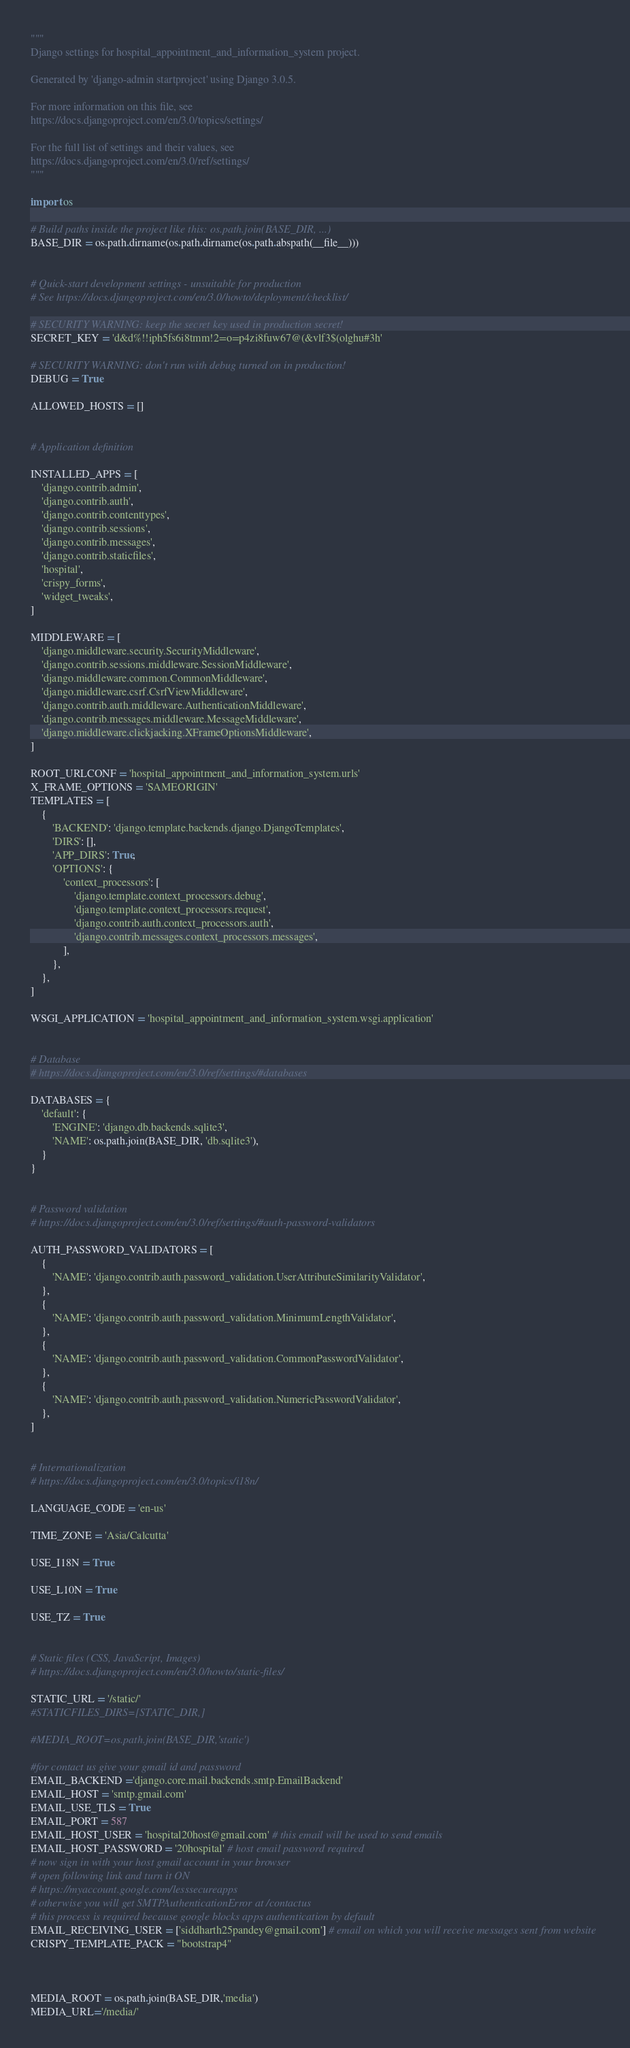<code> <loc_0><loc_0><loc_500><loc_500><_Python_>"""
Django settings for hospital_appointment_and_information_system project.

Generated by 'django-admin startproject' using Django 3.0.5.

For more information on this file, see
https://docs.djangoproject.com/en/3.0/topics/settings/

For the full list of settings and their values, see
https://docs.djangoproject.com/en/3.0/ref/settings/
"""

import os

# Build paths inside the project like this: os.path.join(BASE_DIR, ...)
BASE_DIR = os.path.dirname(os.path.dirname(os.path.abspath(__file__)))


# Quick-start development settings - unsuitable for production
# See https://docs.djangoproject.com/en/3.0/howto/deployment/checklist/

# SECURITY WARNING: keep the secret key used in production secret!
SECRET_KEY = 'd&d%!!iph5fs6i8tmm!2=o=p4zi8fuw67@(&vlf3$(olghu#3h'

# SECURITY WARNING: don't run with debug turned on in production!
DEBUG = True

ALLOWED_HOSTS = []


# Application definition

INSTALLED_APPS = [
    'django.contrib.admin',
    'django.contrib.auth',
    'django.contrib.contenttypes',
    'django.contrib.sessions',
    'django.contrib.messages',
    'django.contrib.staticfiles',
    'hospital',
    'crispy_forms',
    'widget_tweaks',
]

MIDDLEWARE = [
    'django.middleware.security.SecurityMiddleware',
    'django.contrib.sessions.middleware.SessionMiddleware',
    'django.middleware.common.CommonMiddleware',
    'django.middleware.csrf.CsrfViewMiddleware',
    'django.contrib.auth.middleware.AuthenticationMiddleware',
    'django.contrib.messages.middleware.MessageMiddleware',
    'django.middleware.clickjacking.XFrameOptionsMiddleware',
]

ROOT_URLCONF = 'hospital_appointment_and_information_system.urls'
X_FRAME_OPTIONS = 'SAMEORIGIN'
TEMPLATES = [
    {
        'BACKEND': 'django.template.backends.django.DjangoTemplates',
        'DIRS': [],
        'APP_DIRS': True,
        'OPTIONS': {
            'context_processors': [
                'django.template.context_processors.debug',
                'django.template.context_processors.request',
                'django.contrib.auth.context_processors.auth',
                'django.contrib.messages.context_processors.messages',
            ],
        },
    },
]

WSGI_APPLICATION = 'hospital_appointment_and_information_system.wsgi.application'


# Database
# https://docs.djangoproject.com/en/3.0/ref/settings/#databases

DATABASES = {
    'default': {
        'ENGINE': 'django.db.backends.sqlite3',
        'NAME': os.path.join(BASE_DIR, 'db.sqlite3'),
    }
}


# Password validation
# https://docs.djangoproject.com/en/3.0/ref/settings/#auth-password-validators

AUTH_PASSWORD_VALIDATORS = [
    {
        'NAME': 'django.contrib.auth.password_validation.UserAttributeSimilarityValidator',
    },
    {
        'NAME': 'django.contrib.auth.password_validation.MinimumLengthValidator',
    },
    {
        'NAME': 'django.contrib.auth.password_validation.CommonPasswordValidator',
    },
    {
        'NAME': 'django.contrib.auth.password_validation.NumericPasswordValidator',
    },
]


# Internationalization
# https://docs.djangoproject.com/en/3.0/topics/i18n/

LANGUAGE_CODE = 'en-us'

TIME_ZONE = 'Asia/Calcutta'

USE_I18N = True

USE_L10N = True

USE_TZ = True


# Static files (CSS, JavaScript, Images)
# https://docs.djangoproject.com/en/3.0/howto/static-files/

STATIC_URL = '/static/'
#STATICFILES_DIRS=[STATIC_DIR,]

#MEDIA_ROOT=os.path.join(BASE_DIR,'static')

#for contact us give your gmail id and password
EMAIL_BACKEND ='django.core.mail.backends.smtp.EmailBackend'
EMAIL_HOST = 'smtp.gmail.com'
EMAIL_USE_TLS = True
EMAIL_PORT = 587
EMAIL_HOST_USER = 'hospital20host@gmail.com' # this email will be used to send emails
EMAIL_HOST_PASSWORD = '20hospital' # host email password required
# now sign in with your host gmail account in your browser
# open following link and turn it ON
# https://myaccount.google.com/lesssecureapps
# otherwise you will get SMTPAuthenticationError at /contactus
# this process is required because google blocks apps authentication by default
EMAIL_RECEIVING_USER = ['siddharth25pandey@gmail.com'] # email on which you will receive messages sent from website
CRISPY_TEMPLATE_PACK = "bootstrap4"



MEDIA_ROOT = os.path.join(BASE_DIR,'media')
MEDIA_URL='/media/'
</code> 